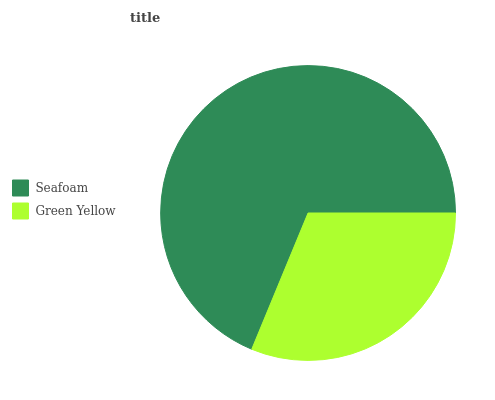Is Green Yellow the minimum?
Answer yes or no. Yes. Is Seafoam the maximum?
Answer yes or no. Yes. Is Green Yellow the maximum?
Answer yes or no. No. Is Seafoam greater than Green Yellow?
Answer yes or no. Yes. Is Green Yellow less than Seafoam?
Answer yes or no. Yes. Is Green Yellow greater than Seafoam?
Answer yes or no. No. Is Seafoam less than Green Yellow?
Answer yes or no. No. Is Seafoam the high median?
Answer yes or no. Yes. Is Green Yellow the low median?
Answer yes or no. Yes. Is Green Yellow the high median?
Answer yes or no. No. Is Seafoam the low median?
Answer yes or no. No. 